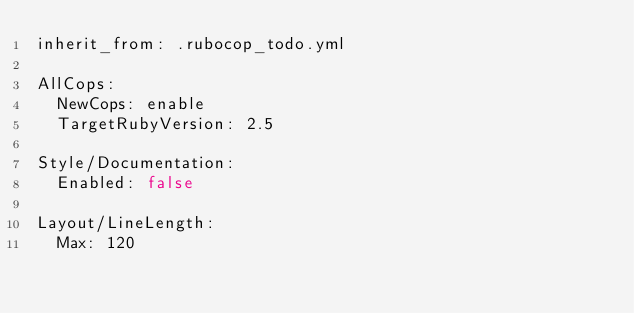<code> <loc_0><loc_0><loc_500><loc_500><_YAML_>inherit_from: .rubocop_todo.yml

AllCops:
  NewCops: enable
  TargetRubyVersion: 2.5

Style/Documentation:
  Enabled: false

Layout/LineLength:
  Max: 120
</code> 